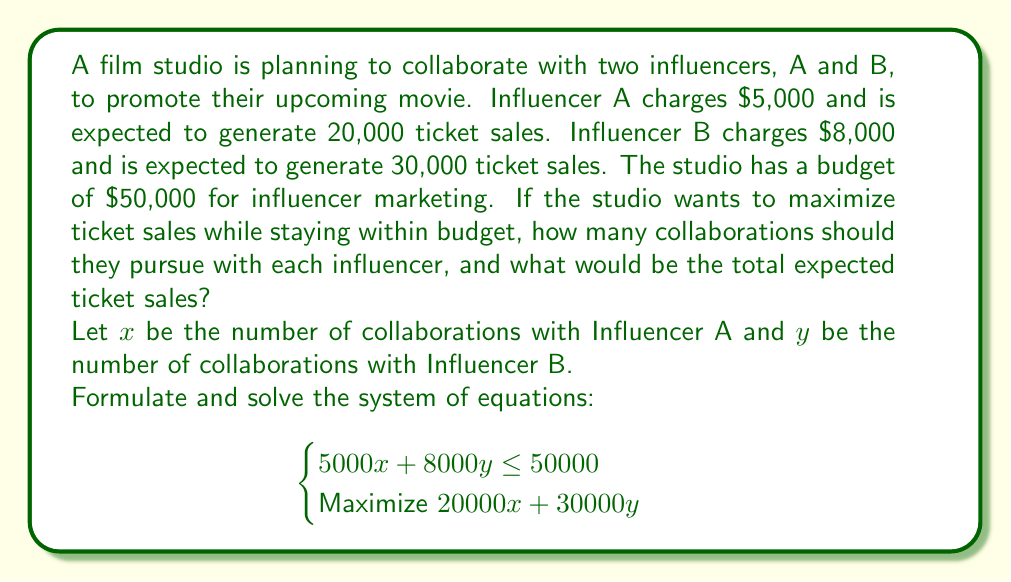Could you help me with this problem? To solve this problem, we'll use linear programming:

1) First, let's graph the constraint equation:
   $$5000x + 8000y = 50000$$
   
   Simplifying: $$5x + 8y = 50$$

2) Find the intercepts:
   When $x = 0$, $y = 6.25$
   When $y = 0$, $x = 10$

3) The feasible region is the area below this line, including the line itself.

4) The corners of the feasible region are:
   (0, 0), (10, 0), and (0, 6.25)

5) Our objective function is:
   $$Z = 20000x + 30000y$$

6) Evaluate Z at each corner:
   At (0, 0): $Z = 0$
   At (10, 0): $Z = 200,000$
   At (0, 6.25): $Z = 187,500$

7) The maximum value occurs at (10, 0), meaning 10 collaborations with Influencer A and 0 with Influencer B.

8) Total expected ticket sales: $20000 * 10 = 200,000$
Answer: 10 collaborations with Influencer A, 0 with Influencer B; 200,000 expected ticket sales 